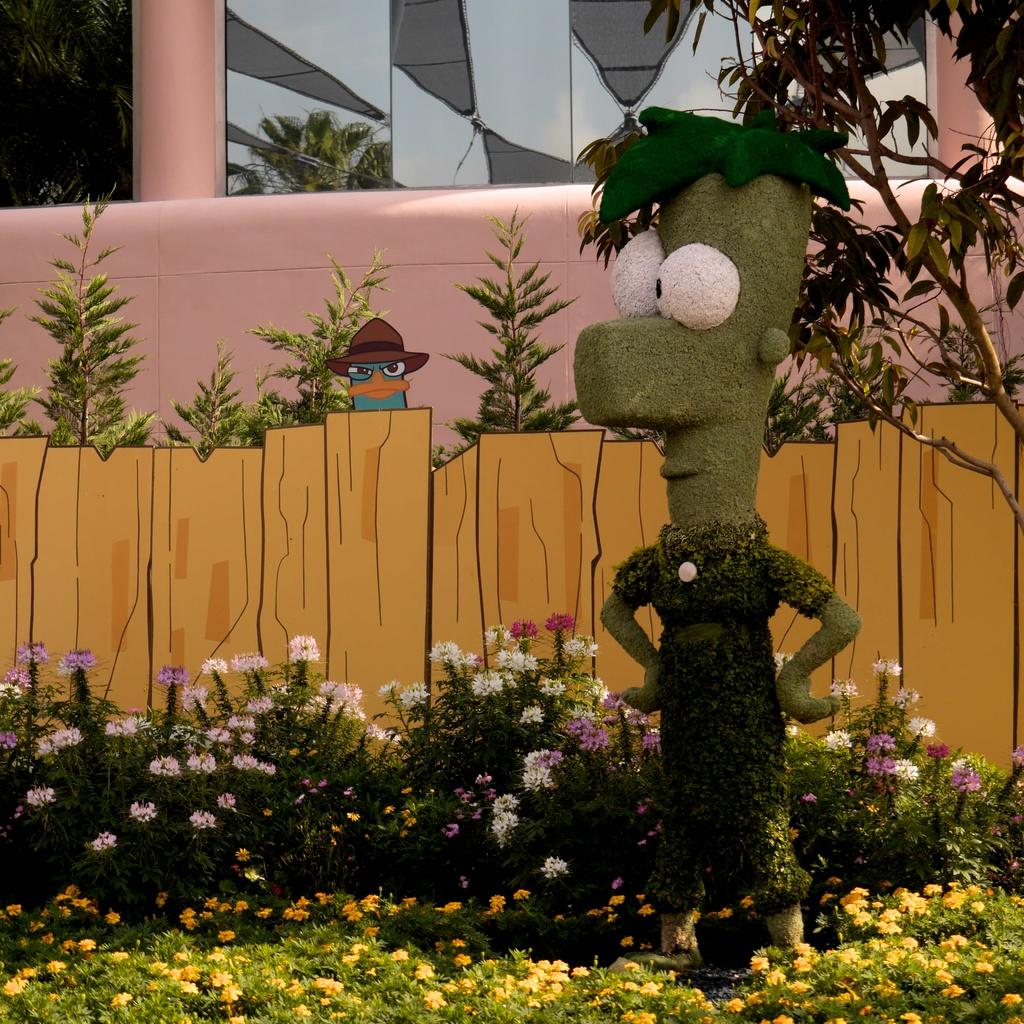What can be found on the right side of the image? There is a toy on the right side of the image. What type of living organisms are present in the image? There are plants and flowers in the image. Where are the plants located in the image? There are plants at the top of the image. What kind of barrier is depicted in the image? There is an animated fence in the image. What additional visual element can be seen in the image? There is a cartoon in the image. What type of structure is visible in the image? There is a building in the image. What advice does the mother bear give to the cubs in the image? There is no mother bear or cubs present in the image; it features a toy, plants, flowers, an animated fence, a cartoon, and a building. What is the rate of the animated fence in the image? The animated fence in the image does not have a rate, as it is a static visual element. 